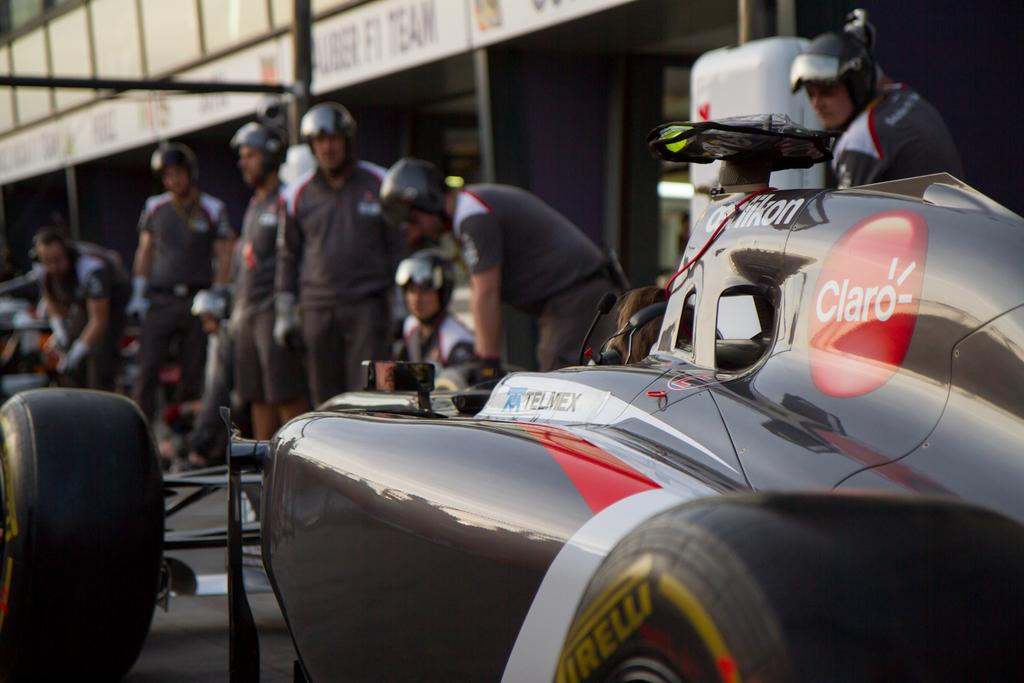What are the people in the image doing? The people in the image are standing on the road. What are the people wearing on their heads? The people are wearing helmets. What can be seen on the road in the image? There is a black vehicle on the road. Can you describe the background of the image? The background of the image is blurred. Where are the friends sitting in the image? There is no mention of friends in the image, and no chairs or seating are visible. 